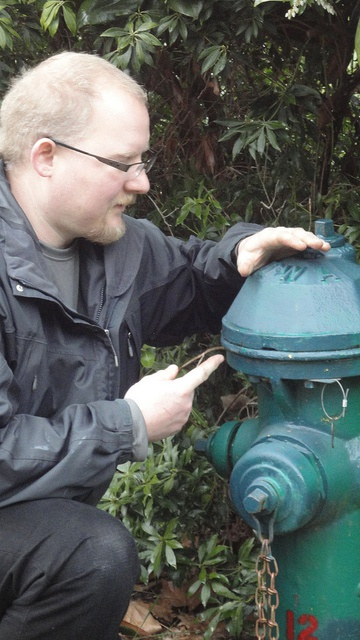Describe the objects in this image and their specific colors. I can see people in darkgreen, gray, black, lightgray, and darkgray tones and fire hydrant in darkgreen, teal, and lightblue tones in this image. 